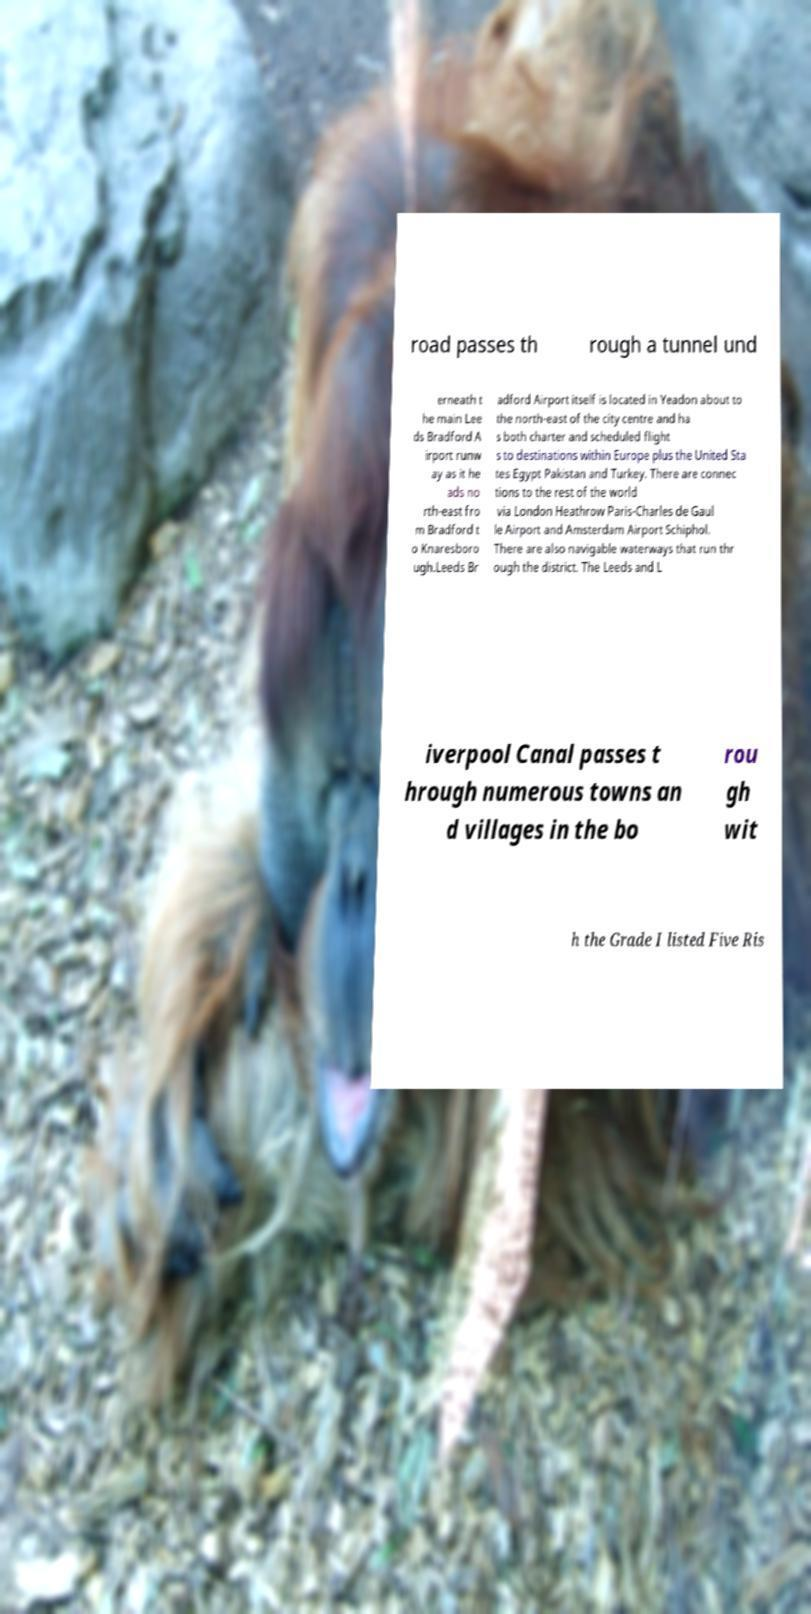I need the written content from this picture converted into text. Can you do that? road passes th rough a tunnel und erneath t he main Lee ds Bradford A irport runw ay as it he ads no rth-east fro m Bradford t o Knaresboro ugh.Leeds Br adford Airport itself is located in Yeadon about to the north-east of the city centre and ha s both charter and scheduled flight s to destinations within Europe plus the United Sta tes Egypt Pakistan and Turkey. There are connec tions to the rest of the world via London Heathrow Paris-Charles de Gaul le Airport and Amsterdam Airport Schiphol. There are also navigable waterways that run thr ough the district. The Leeds and L iverpool Canal passes t hrough numerous towns an d villages in the bo rou gh wit h the Grade I listed Five Ris 